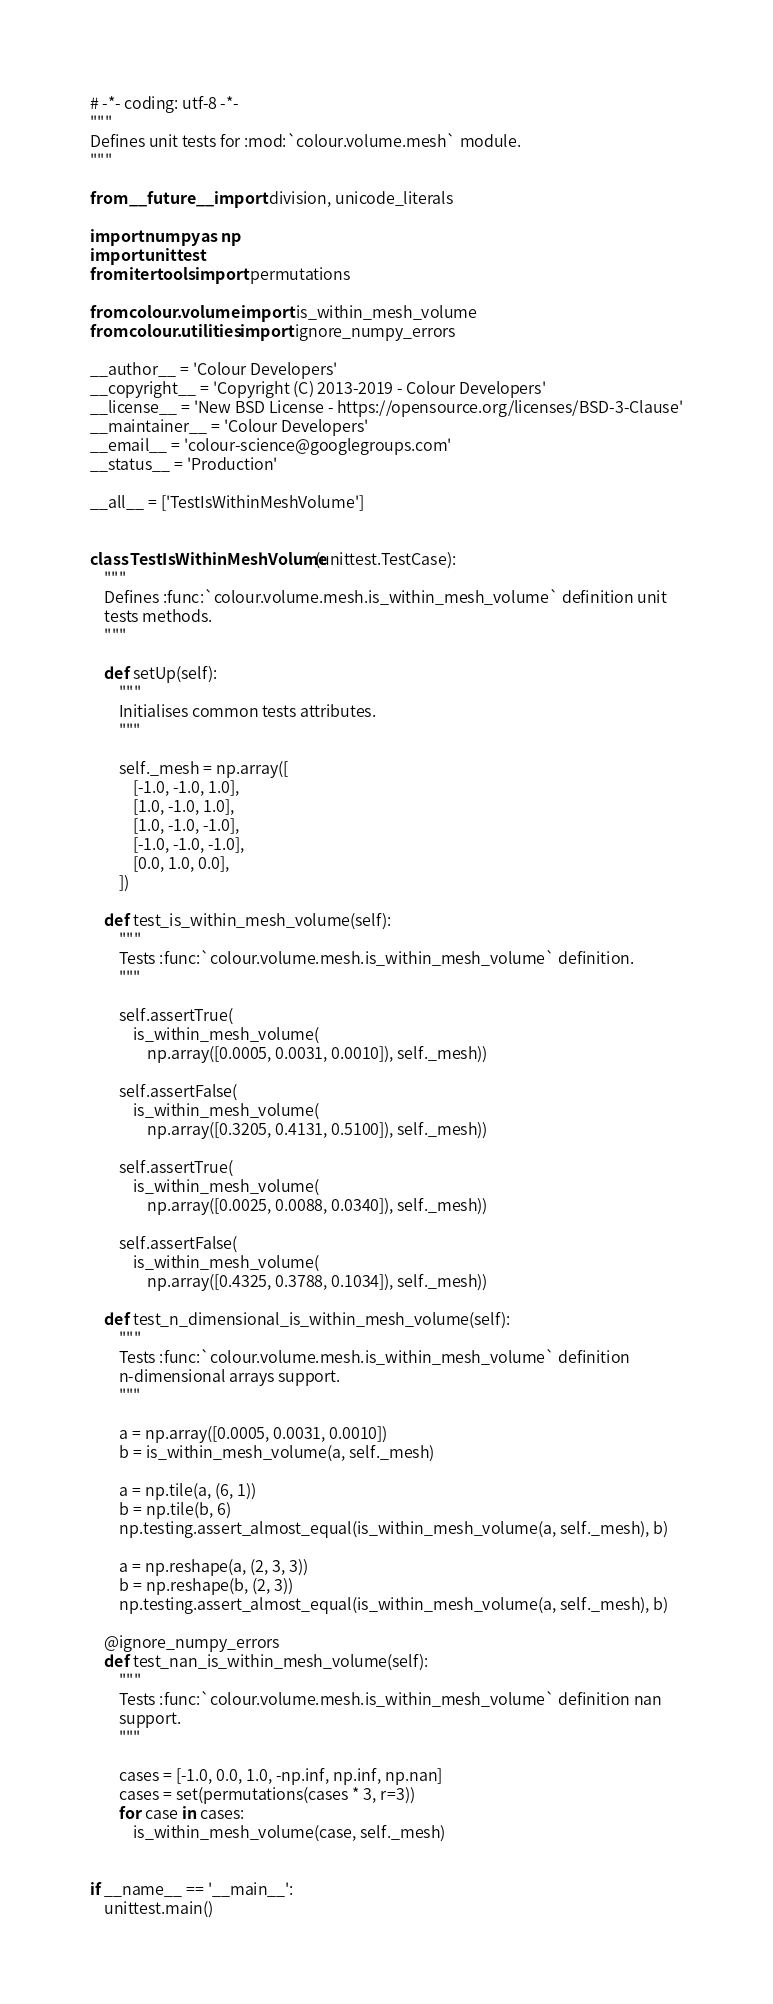<code> <loc_0><loc_0><loc_500><loc_500><_Python_># -*- coding: utf-8 -*-
"""
Defines unit tests for :mod:`colour.volume.mesh` module.
"""

from __future__ import division, unicode_literals

import numpy as np
import unittest
from itertools import permutations

from colour.volume import is_within_mesh_volume
from colour.utilities import ignore_numpy_errors

__author__ = 'Colour Developers'
__copyright__ = 'Copyright (C) 2013-2019 - Colour Developers'
__license__ = 'New BSD License - https://opensource.org/licenses/BSD-3-Clause'
__maintainer__ = 'Colour Developers'
__email__ = 'colour-science@googlegroups.com'
__status__ = 'Production'

__all__ = ['TestIsWithinMeshVolume']


class TestIsWithinMeshVolume(unittest.TestCase):
    """
    Defines :func:`colour.volume.mesh.is_within_mesh_volume` definition unit
    tests methods.
    """

    def setUp(self):
        """
        Initialises common tests attributes.
        """

        self._mesh = np.array([
            [-1.0, -1.0, 1.0],
            [1.0, -1.0, 1.0],
            [1.0, -1.0, -1.0],
            [-1.0, -1.0, -1.0],
            [0.0, 1.0, 0.0],
        ])

    def test_is_within_mesh_volume(self):
        """
        Tests :func:`colour.volume.mesh.is_within_mesh_volume` definition.
        """

        self.assertTrue(
            is_within_mesh_volume(
                np.array([0.0005, 0.0031, 0.0010]), self._mesh))

        self.assertFalse(
            is_within_mesh_volume(
                np.array([0.3205, 0.4131, 0.5100]), self._mesh))

        self.assertTrue(
            is_within_mesh_volume(
                np.array([0.0025, 0.0088, 0.0340]), self._mesh))

        self.assertFalse(
            is_within_mesh_volume(
                np.array([0.4325, 0.3788, 0.1034]), self._mesh))

    def test_n_dimensional_is_within_mesh_volume(self):
        """
        Tests :func:`colour.volume.mesh.is_within_mesh_volume` definition
        n-dimensional arrays support.
        """

        a = np.array([0.0005, 0.0031, 0.0010])
        b = is_within_mesh_volume(a, self._mesh)

        a = np.tile(a, (6, 1))
        b = np.tile(b, 6)
        np.testing.assert_almost_equal(is_within_mesh_volume(a, self._mesh), b)

        a = np.reshape(a, (2, 3, 3))
        b = np.reshape(b, (2, 3))
        np.testing.assert_almost_equal(is_within_mesh_volume(a, self._mesh), b)

    @ignore_numpy_errors
    def test_nan_is_within_mesh_volume(self):
        """
        Tests :func:`colour.volume.mesh.is_within_mesh_volume` definition nan
        support.
        """

        cases = [-1.0, 0.0, 1.0, -np.inf, np.inf, np.nan]
        cases = set(permutations(cases * 3, r=3))
        for case in cases:
            is_within_mesh_volume(case, self._mesh)


if __name__ == '__main__':
    unittest.main()
</code> 